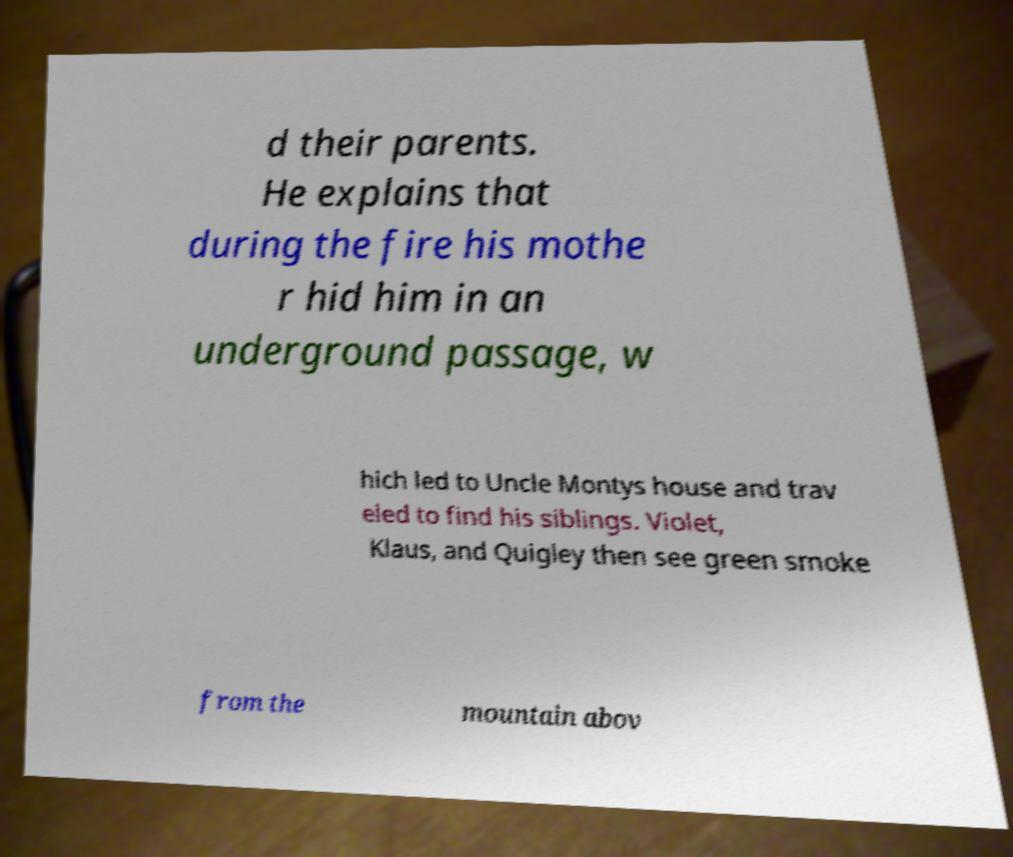Please read and relay the text visible in this image. What does it say? d their parents. He explains that during the fire his mothe r hid him in an underground passage, w hich led to Uncle Montys house and trav eled to find his siblings. Violet, Klaus, and Quigley then see green smoke from the mountain abov 